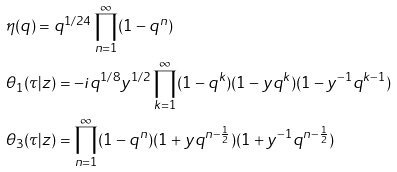<formula> <loc_0><loc_0><loc_500><loc_500>& \eta ( q ) = q ^ { 1 / 2 4 } \prod _ { n = 1 } ^ { \infty } ( 1 - q ^ { n } ) \\ & \theta _ { 1 } ( \tau | z ) = - i q ^ { 1 / 8 } y ^ { 1 / 2 } \prod _ { k = 1 } ^ { \infty } ( 1 - q ^ { k } ) ( 1 - y q ^ { k } ) ( 1 - y ^ { - 1 } q ^ { k - 1 } ) \\ & \theta _ { 3 } ( \tau | z ) = \prod _ { n = 1 } ^ { \infty } ( 1 - q ^ { n } ) ( 1 + y q ^ { n - \frac { 1 } { 2 } } ) ( 1 + y ^ { - 1 } q ^ { n - \frac { 1 } { 2 } } )</formula> 